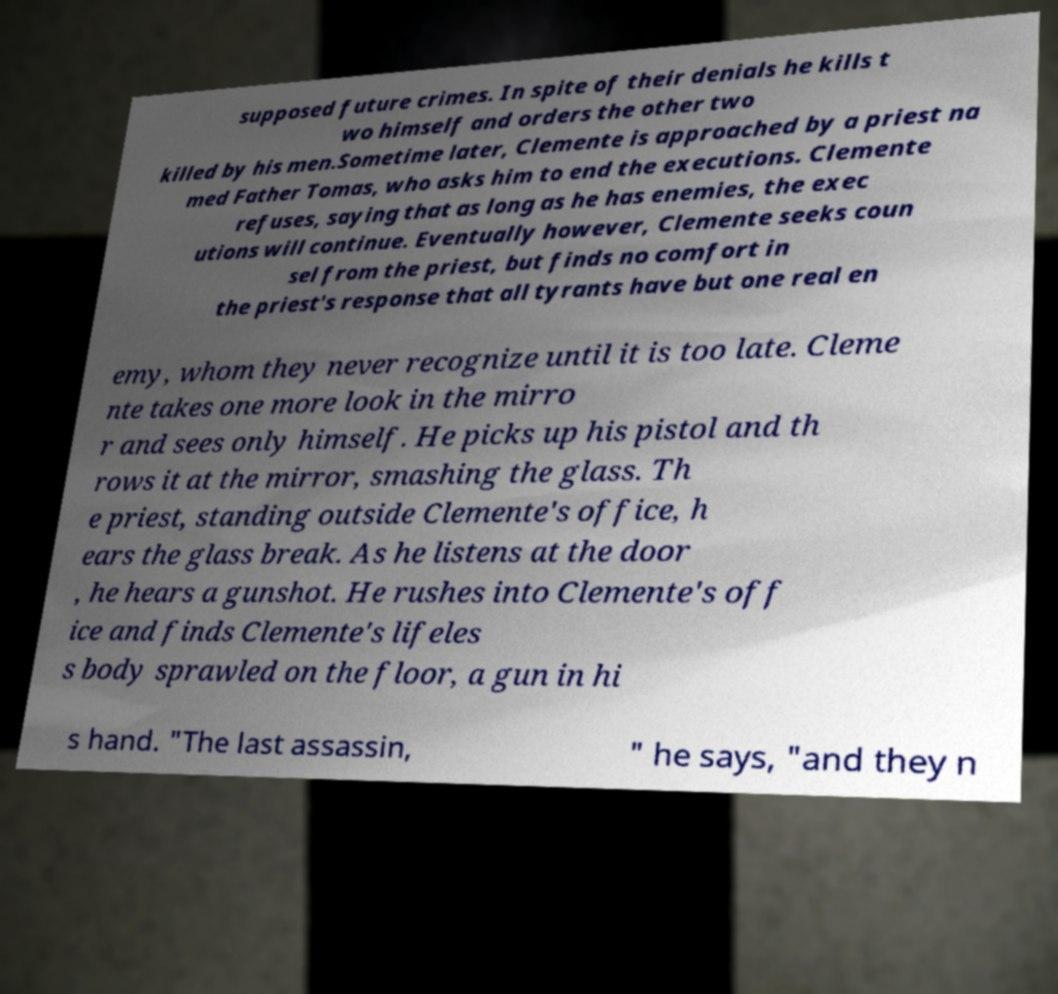Please identify and transcribe the text found in this image. supposed future crimes. In spite of their denials he kills t wo himself and orders the other two killed by his men.Sometime later, Clemente is approached by a priest na med Father Tomas, who asks him to end the executions. Clemente refuses, saying that as long as he has enemies, the exec utions will continue. Eventually however, Clemente seeks coun sel from the priest, but finds no comfort in the priest's response that all tyrants have but one real en emy, whom they never recognize until it is too late. Cleme nte takes one more look in the mirro r and sees only himself. He picks up his pistol and th rows it at the mirror, smashing the glass. Th e priest, standing outside Clemente's office, h ears the glass break. As he listens at the door , he hears a gunshot. He rushes into Clemente's off ice and finds Clemente's lifeles s body sprawled on the floor, a gun in hi s hand. "The last assassin, " he says, "and they n 